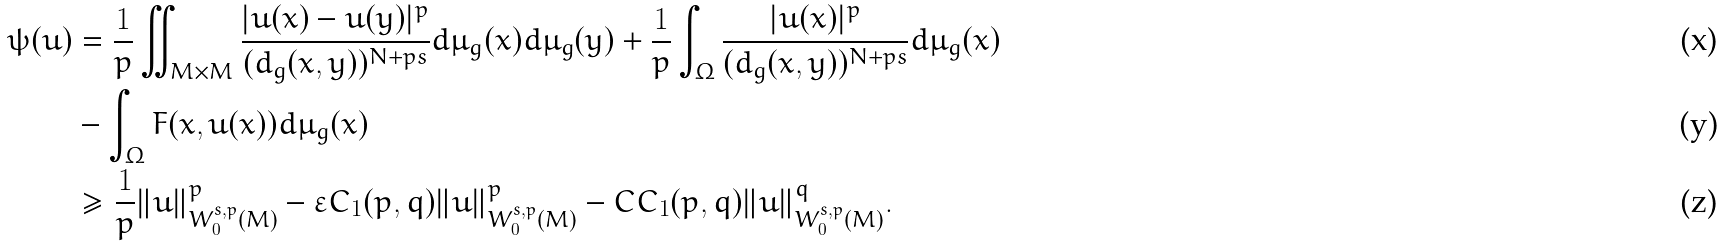Convert formula to latex. <formula><loc_0><loc_0><loc_500><loc_500>\psi ( u ) & = \frac { 1 } { p } \iint _ { M \times M } \frac { | u ( x ) - u ( y ) | ^ { p } } { ( d _ { g } ( x , y ) ) ^ { N + p s } } d \mu _ { g } ( x ) d \mu _ { g } ( y ) + \frac { 1 } { p } \int _ { \Omega } \frac { | u ( x ) | ^ { p } } { ( d _ { g } ( x , y ) ) ^ { N + p s } } d \mu _ { g } ( x ) \\ & - \int _ { \Omega } F ( x , u ( x ) ) d \mu _ { g } ( x ) \\ & \geq \frac { 1 } { p } \| u \| ^ { p } _ { W _ { 0 } ^ { s , p } ( M ) } - \varepsilon C _ { 1 } ( p , q ) \| u \| ^ { p } _ { W _ { 0 } ^ { s , p } ( M ) } - C C _ { 1 } ( p , q ) \| u \| ^ { q } _ { W _ { 0 } ^ { s , p } ( M ) } .</formula> 